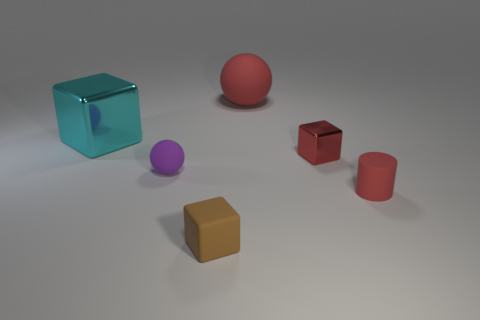There is a cylinder that is the same color as the small metal object; what is its size?
Your response must be concise. Small. There is a rubber thing that is the same color as the tiny rubber cylinder; what is its shape?
Offer a terse response. Sphere. There is a large metal block; are there any small brown matte things on the right side of it?
Your answer should be compact. Yes. Are there fewer blocks right of the tiny red cube than large green balls?
Provide a succinct answer. No. What material is the tiny brown object?
Offer a terse response. Rubber. The small rubber block is what color?
Your answer should be compact. Brown. There is a cube that is behind the small purple rubber ball and right of the purple matte thing; what color is it?
Your response must be concise. Red. Are there any other things that are made of the same material as the red cube?
Offer a terse response. Yes. Do the purple thing and the object behind the large cyan metallic object have the same material?
Provide a short and direct response. Yes. What size is the ball in front of the large object on the left side of the tiny matte block?
Keep it short and to the point. Small. 